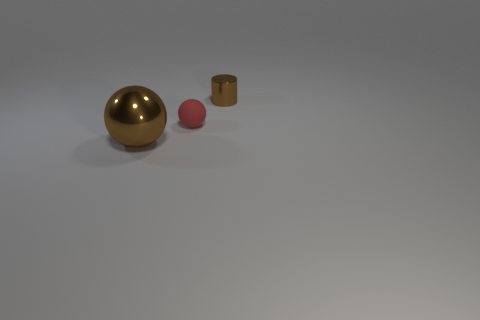How many small things are either brown cylinders or red spheres?
Offer a terse response. 2. Is the number of large brown shiny things in front of the large brown sphere less than the number of tiny brown metallic things that are behind the brown metallic cylinder?
Offer a very short reply. No. What number of things are small red things or tiny brown metallic objects?
Offer a terse response. 2. There is a matte ball; what number of objects are on the left side of it?
Make the answer very short. 1. Do the small metal thing and the big thing have the same color?
Your answer should be very brief. Yes. There is a big brown object that is the same material as the tiny brown cylinder; what shape is it?
Offer a very short reply. Sphere. Does the object to the left of the small red sphere have the same shape as the tiny red rubber thing?
Make the answer very short. Yes. How many brown things are metallic things or rubber spheres?
Make the answer very short. 2. Is the number of big brown metal spheres behind the large brown metallic sphere the same as the number of big brown metal balls that are right of the tiny sphere?
Make the answer very short. Yes. There is a metal thing that is to the left of the brown object that is on the right side of the brown metal object to the left of the small brown cylinder; what color is it?
Make the answer very short. Brown. 